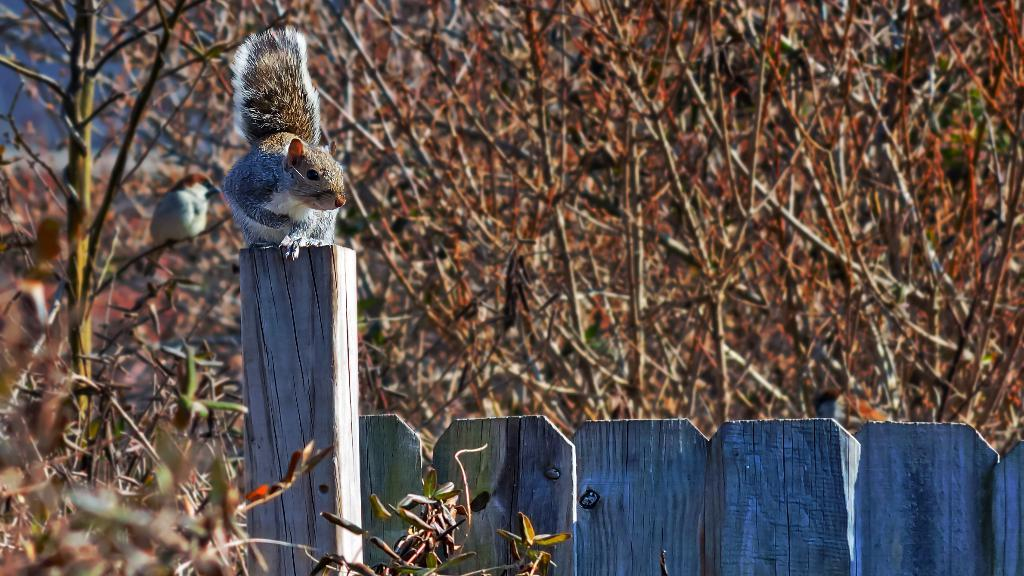What animal can be seen on the wood in the image? There is a squirrel on the wood in the image. What type of natural environment is depicted in the image? There are trees in the background of the image, suggesting a forest or wooded area. Can any other animals be seen in the image? Yes, there is a bird visible in the background of the image. What type of shop can be seen in the image? There is no shop present in the image; it features a squirrel on wood with trees and a bird in the background. How does the squirrel use the twig in the image? There is no twig present in the image; the squirrel is simply sitting on the wood. 